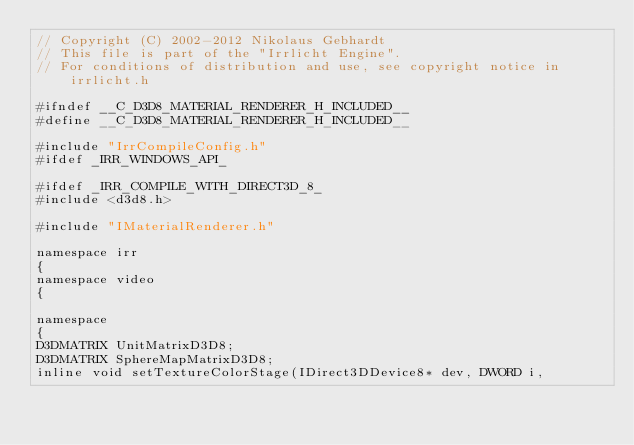<code> <loc_0><loc_0><loc_500><loc_500><_C_>// Copyright (C) 2002-2012 Nikolaus Gebhardt
// This file is part of the "Irrlicht Engine".
// For conditions of distribution and use, see copyright notice in irrlicht.h

#ifndef __C_D3D8_MATERIAL_RENDERER_H_INCLUDED__
#define __C_D3D8_MATERIAL_RENDERER_H_INCLUDED__

#include "IrrCompileConfig.h"
#ifdef _IRR_WINDOWS_API_

#ifdef _IRR_COMPILE_WITH_DIRECT3D_8_
#include <d3d8.h>

#include "IMaterialRenderer.h"

namespace irr
{
namespace video
{

namespace
{
D3DMATRIX UnitMatrixD3D8;
D3DMATRIX SphereMapMatrixD3D8;
inline void setTextureColorStage(IDirect3DDevice8* dev, DWORD i,</code> 